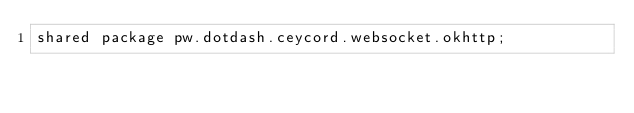Convert code to text. <code><loc_0><loc_0><loc_500><loc_500><_Ceylon_>shared package pw.dotdash.ceycord.websocket.okhttp;</code> 